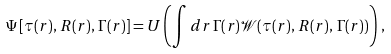Convert formula to latex. <formula><loc_0><loc_0><loc_500><loc_500>\Psi \left [ \tau ( r ) , \, R ( r ) , \, \Gamma ( r ) \right ] = U \left ( \int d r \, \Gamma ( r ) \mathcal { W } ( \tau ( r ) , \, R ( r ) , \, \Gamma ( r ) ) \right ) \, ,</formula> 